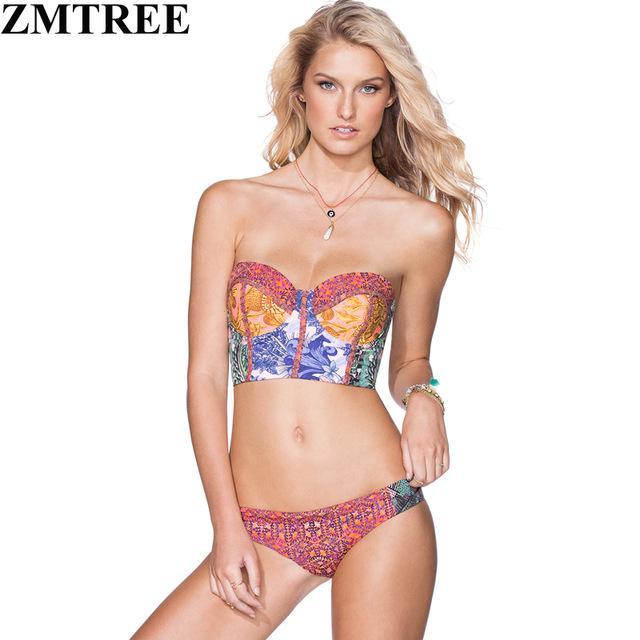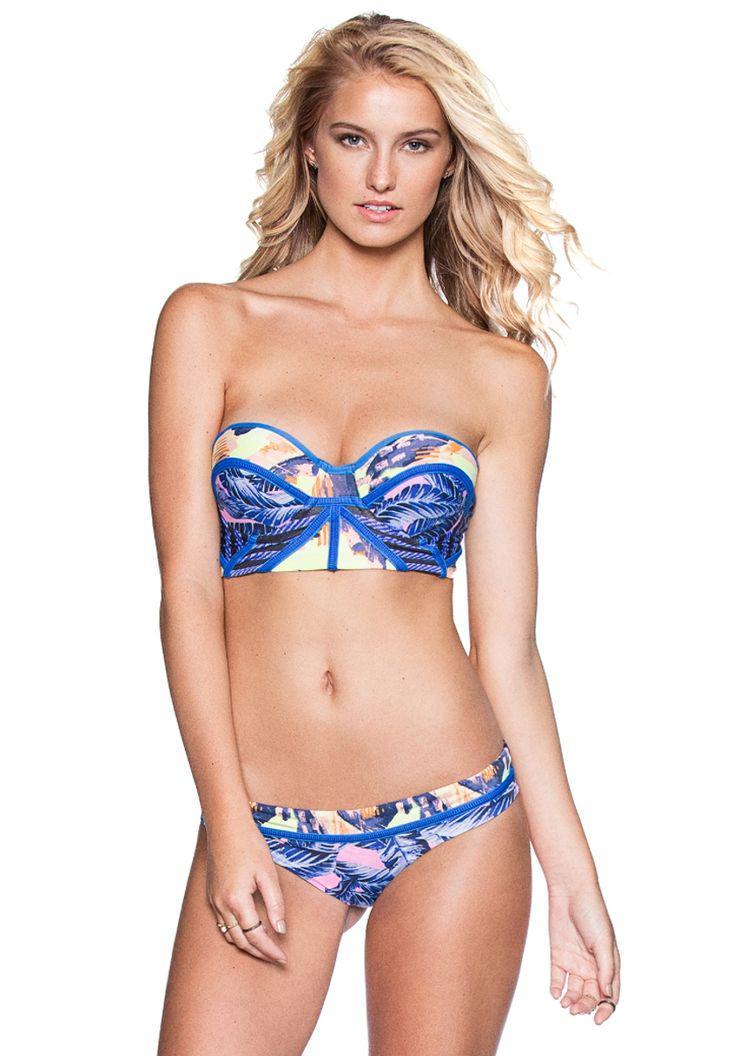The first image is the image on the left, the second image is the image on the right. Considering the images on both sides, is "One bikini is tied with bows." valid? Answer yes or no. No. 